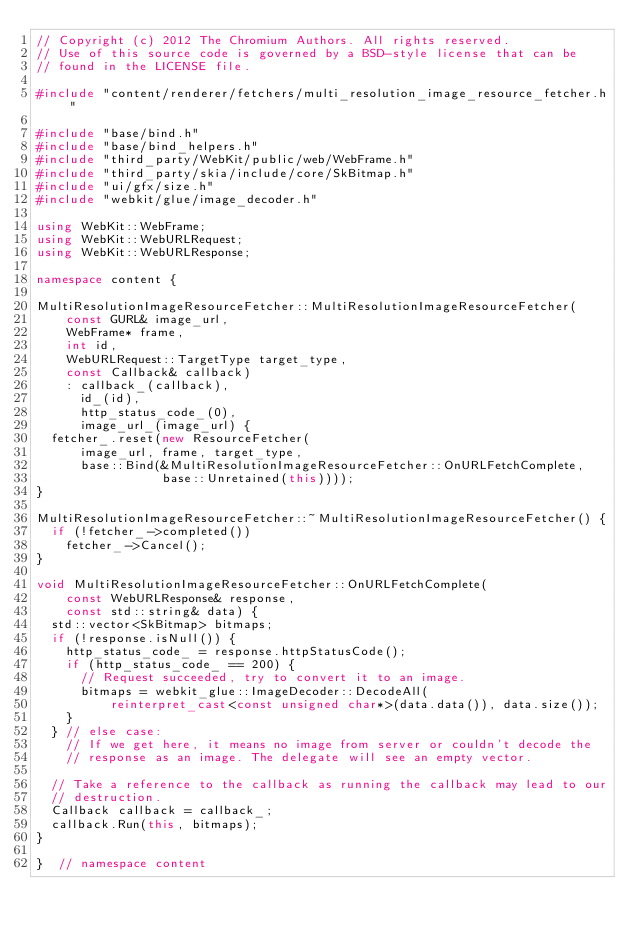<code> <loc_0><loc_0><loc_500><loc_500><_C++_>// Copyright (c) 2012 The Chromium Authors. All rights reserved.
// Use of this source code is governed by a BSD-style license that can be
// found in the LICENSE file.

#include "content/renderer/fetchers/multi_resolution_image_resource_fetcher.h"

#include "base/bind.h"
#include "base/bind_helpers.h"
#include "third_party/WebKit/public/web/WebFrame.h"
#include "third_party/skia/include/core/SkBitmap.h"
#include "ui/gfx/size.h"
#include "webkit/glue/image_decoder.h"

using WebKit::WebFrame;
using WebKit::WebURLRequest;
using WebKit::WebURLResponse;

namespace content {

MultiResolutionImageResourceFetcher::MultiResolutionImageResourceFetcher(
    const GURL& image_url,
    WebFrame* frame,
    int id,
    WebURLRequest::TargetType target_type,
    const Callback& callback)
    : callback_(callback),
      id_(id),
      http_status_code_(0),
      image_url_(image_url) {
  fetcher_.reset(new ResourceFetcher(
      image_url, frame, target_type,
      base::Bind(&MultiResolutionImageResourceFetcher::OnURLFetchComplete,
                 base::Unretained(this))));
}

MultiResolutionImageResourceFetcher::~MultiResolutionImageResourceFetcher() {
  if (!fetcher_->completed())
    fetcher_->Cancel();
}

void MultiResolutionImageResourceFetcher::OnURLFetchComplete(
    const WebURLResponse& response,
    const std::string& data) {
  std::vector<SkBitmap> bitmaps;
  if (!response.isNull()) {
    http_status_code_ = response.httpStatusCode();
    if (http_status_code_ == 200) {
      // Request succeeded, try to convert it to an image.
      bitmaps = webkit_glue::ImageDecoder::DecodeAll(
          reinterpret_cast<const unsigned char*>(data.data()), data.size());
    }
  } // else case:
    // If we get here, it means no image from server or couldn't decode the
    // response as an image. The delegate will see an empty vector.

  // Take a reference to the callback as running the callback may lead to our
  // destruction.
  Callback callback = callback_;
  callback.Run(this, bitmaps);
}

}  // namespace content
</code> 